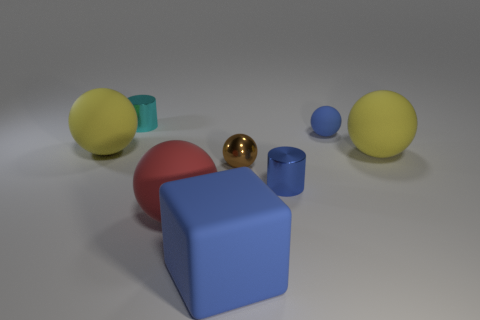Subtract all blue spheres. How many spheres are left? 4 Subtract all blue balls. How many balls are left? 4 Subtract all purple balls. Subtract all cyan cylinders. How many balls are left? 5 Add 1 small purple cubes. How many objects exist? 9 Subtract all blocks. How many objects are left? 7 Subtract all small brown rubber blocks. Subtract all metallic spheres. How many objects are left? 7 Add 2 blue cylinders. How many blue cylinders are left? 3 Add 1 brown balls. How many brown balls exist? 2 Subtract 0 cyan cubes. How many objects are left? 8 